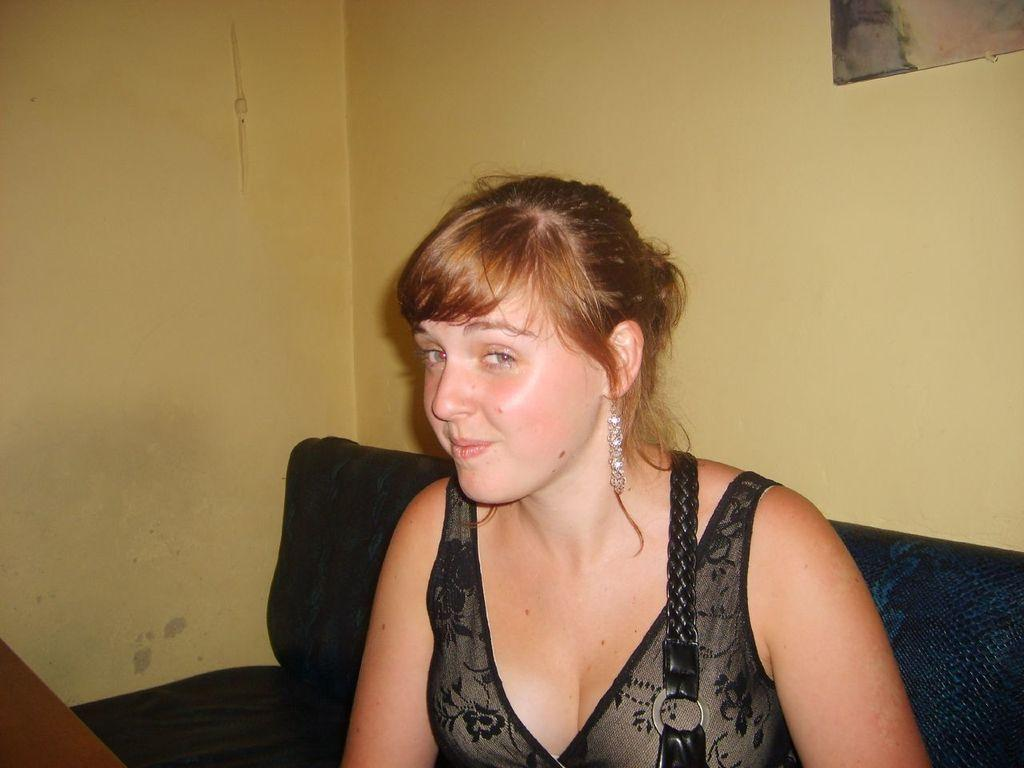Who is present in the image? There is a woman in the image. What is the woman doing in the image? The woman is sitting on a sofa. What can be seen in the background of the image? There is a photo frame on the wall in the background of the image. What type of leather material is the donkey made of in the image? There is no donkey present in the image, so it is not possible to determine the type of leather material it might be made of. 